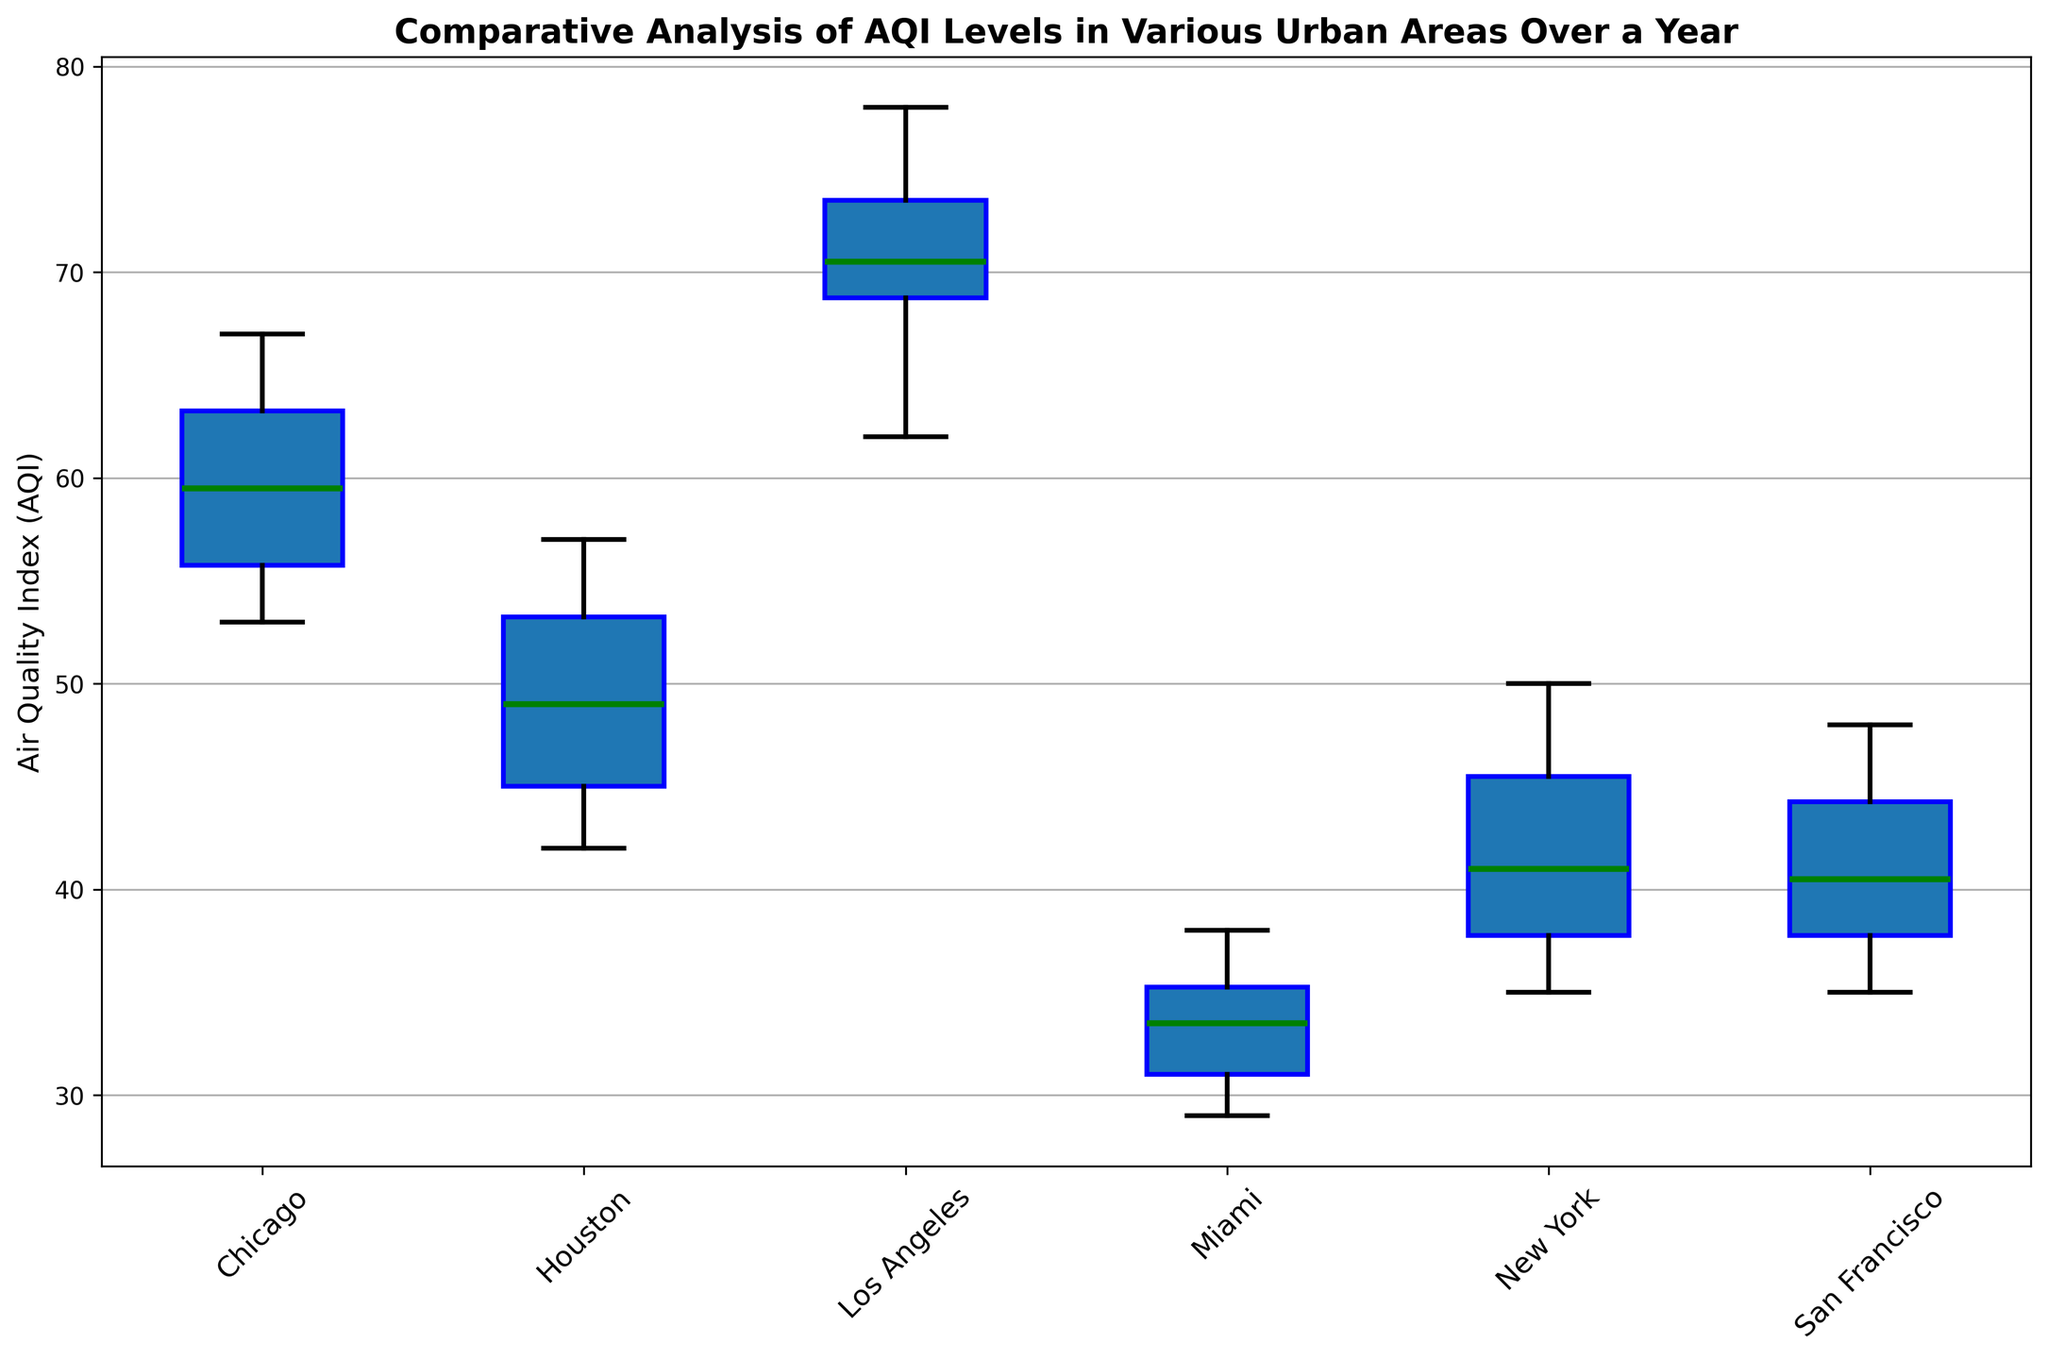What is the range of AQI values for Los Angeles? To find the range of AQI values, subtract the minimum AQI value from the maximum AQI value. Based on the figure, the minimum AQI value in Los Angeles appears to be around 62 (the lower whisker), and the maximum AQI value is around 78 (the upper whisker). Thus, the range is 78 - 62.
Answer: 16 Which city has the highest median AQI value? To determine the city with the highest median AQI value, look at the middle line inside the box for each city. In the figure, the median line for Los Angeles is higher compared to that of other cities.
Answer: Los Angeles How do the interquartile ranges (IQRs) of New York and Miami compare? To compare the interquartile ranges (IQRs), observe the height of the boxes for both cities. The IQR is the difference between the upper quartile (top edge of the box) and the lower quartile (bottom edge of the box). New York's box appears larger than Miami's, indicating a higher IQR.
Answer: New York has a higher IQR than Miami Which city has the smallest interquartile range (IQR)? To find the city with the smallest IQR, look for the shortest box plot among the cities. Miami's box plot has the smallest IQR as it's the shortest.
Answer: Miami What is the approximate median AQI value for Chicago? The median AQI value is represented by the horizontal line within the box. For Chicago, this line appears around 59 or 60.
Answer: Approximately 59 How does the spread of AQI values for Houston compare to San Francisco? To compare the spread, look at the length of the whiskers and the height of the boxes for both cities. Houston's box and whiskers are slightly wider/broader than those of San Francisco, indicating a larger spread of AQI values in Houston.
Answer: Houston has a larger spread than San Francisco Which city has the lowest AQI value? To determine the city with the lowest AQI value, check the lowest end of the whiskers across all cities. Miami's lower whisker reaches down to the lowest point, around 29.
Answer: Miami Which city shows the most consistent air quality throughout the year? Consistency in AQI can be judged by the size of the box and the length of the whiskers; smaller these are, the more consistent the air quality. Miami has the smallest box and whiskers, indicating the most consistent air quality.
Answer: Miami 